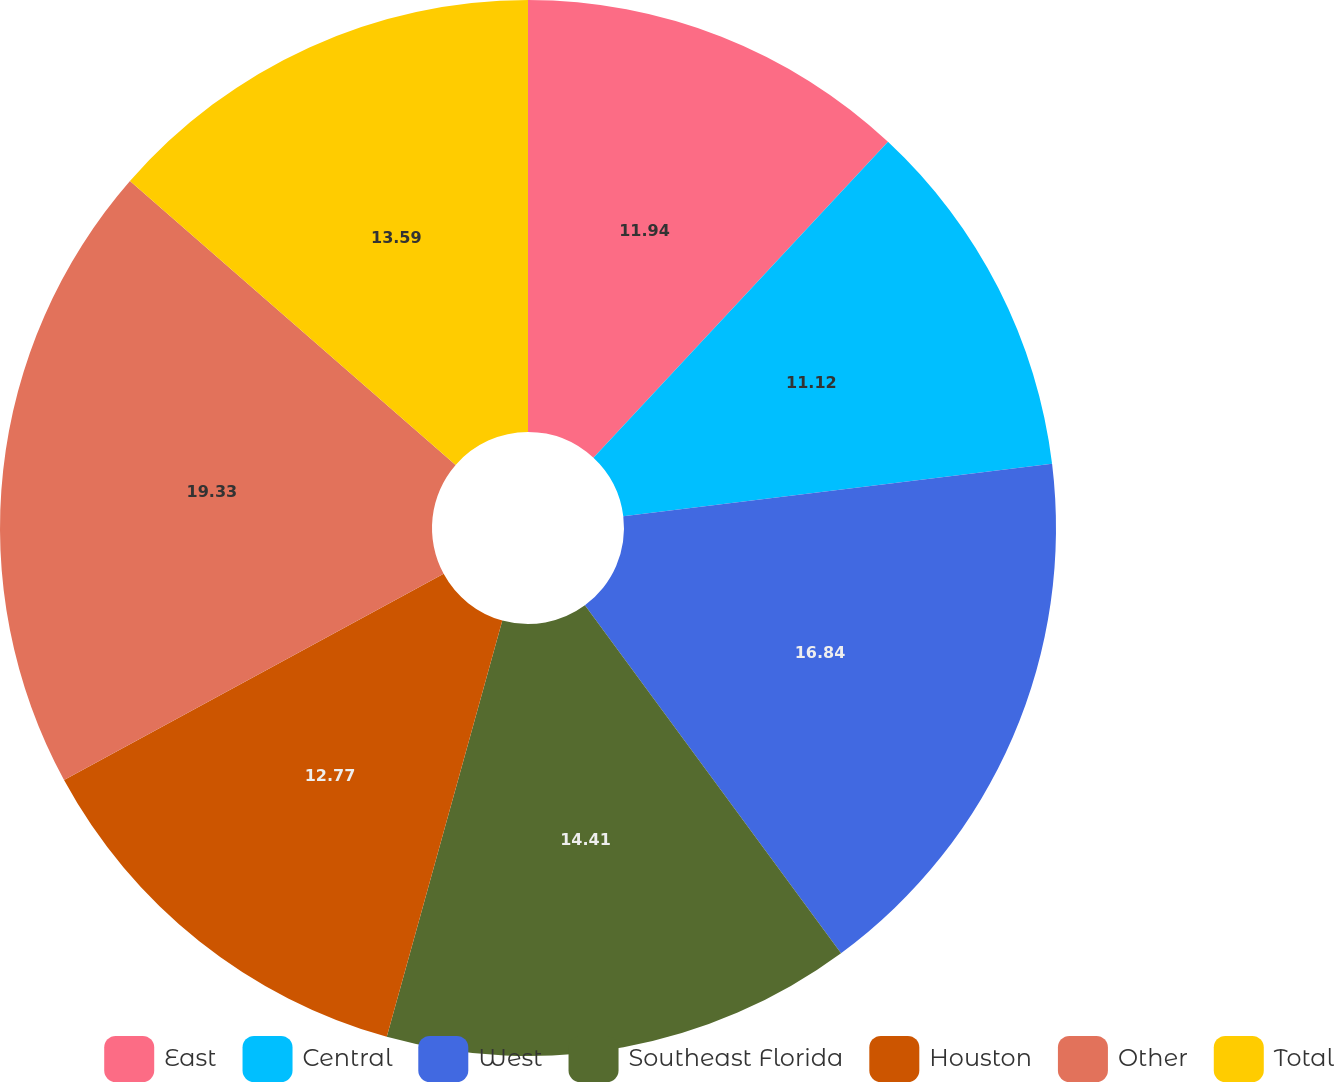Convert chart. <chart><loc_0><loc_0><loc_500><loc_500><pie_chart><fcel>East<fcel>Central<fcel>West<fcel>Southeast Florida<fcel>Houston<fcel>Other<fcel>Total<nl><fcel>11.94%<fcel>11.12%<fcel>16.84%<fcel>14.41%<fcel>12.77%<fcel>19.33%<fcel>13.59%<nl></chart> 